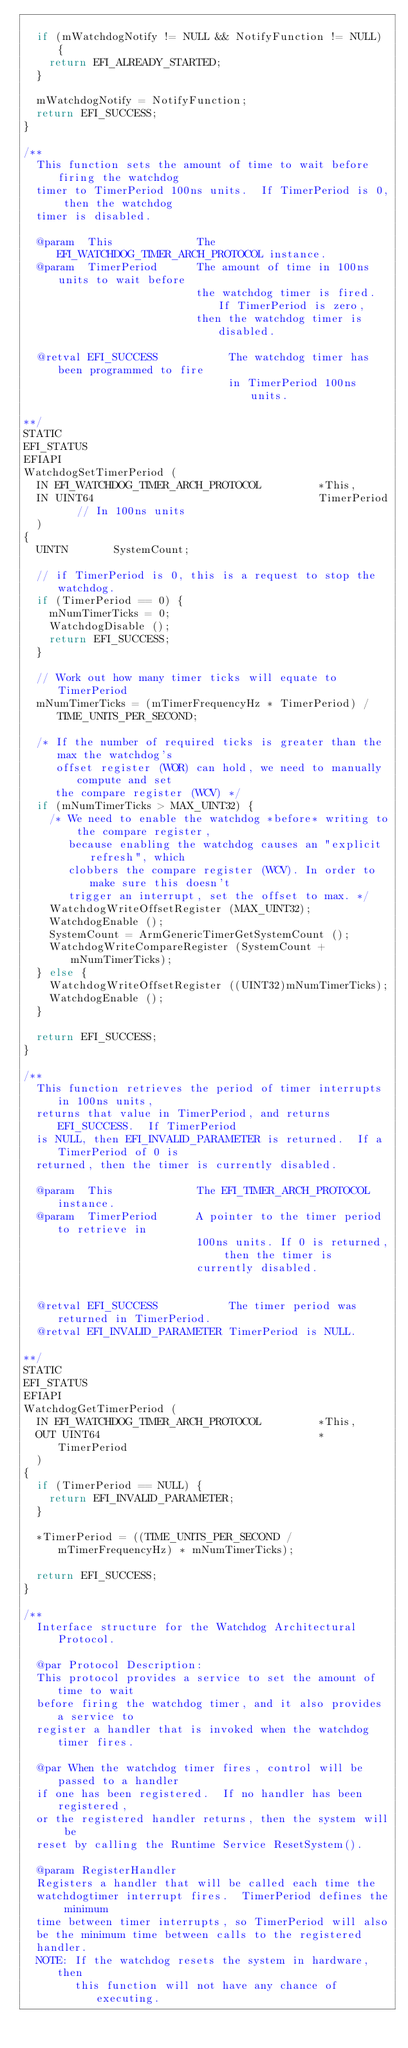Convert code to text. <code><loc_0><loc_0><loc_500><loc_500><_C_>
  if (mWatchdogNotify != NULL && NotifyFunction != NULL) {
    return EFI_ALREADY_STARTED;
  }

  mWatchdogNotify = NotifyFunction;
  return EFI_SUCCESS;
}

/**
  This function sets the amount of time to wait before firing the watchdog
  timer to TimerPeriod 100ns units.  If TimerPeriod is 0, then the watchdog
  timer is disabled.

  @param  This             The EFI_WATCHDOG_TIMER_ARCH_PROTOCOL instance.
  @param  TimerPeriod      The amount of time in 100ns units to wait before
                           the watchdog timer is fired. If TimerPeriod is zero,
                           then the watchdog timer is disabled.

  @retval EFI_SUCCESS           The watchdog timer has been programmed to fire
                                in TimerPeriod 100ns units.

**/
STATIC
EFI_STATUS
EFIAPI
WatchdogSetTimerPeriod (
  IN EFI_WATCHDOG_TIMER_ARCH_PROTOCOL         *This,
  IN UINT64                                   TimerPeriod   // In 100ns units
  )
{
  UINTN       SystemCount;

  // if TimerPeriod is 0, this is a request to stop the watchdog.
  if (TimerPeriod == 0) {
    mNumTimerTicks = 0;
    WatchdogDisable ();
    return EFI_SUCCESS;
  }

  // Work out how many timer ticks will equate to TimerPeriod
  mNumTimerTicks = (mTimerFrequencyHz * TimerPeriod) / TIME_UNITS_PER_SECOND;

  /* If the number of required ticks is greater than the max the watchdog's
     offset register (WOR) can hold, we need to manually compute and set
     the compare register (WCV) */
  if (mNumTimerTicks > MAX_UINT32) {
    /* We need to enable the watchdog *before* writing to the compare register,
       because enabling the watchdog causes an "explicit refresh", which
       clobbers the compare register (WCV). In order to make sure this doesn't
       trigger an interrupt, set the offset to max. */
    WatchdogWriteOffsetRegister (MAX_UINT32);
    WatchdogEnable ();
    SystemCount = ArmGenericTimerGetSystemCount ();
    WatchdogWriteCompareRegister (SystemCount + mNumTimerTicks);
  } else {
    WatchdogWriteOffsetRegister ((UINT32)mNumTimerTicks);
    WatchdogEnable ();
  }

  return EFI_SUCCESS;
}

/**
  This function retrieves the period of timer interrupts in 100ns units,
  returns that value in TimerPeriod, and returns EFI_SUCCESS.  If TimerPeriod
  is NULL, then EFI_INVALID_PARAMETER is returned.  If a TimerPeriod of 0 is
  returned, then the timer is currently disabled.

  @param  This             The EFI_TIMER_ARCH_PROTOCOL instance.
  @param  TimerPeriod      A pointer to the timer period to retrieve in
                           100ns units. If 0 is returned, then the timer is
                           currently disabled.


  @retval EFI_SUCCESS           The timer period was returned in TimerPeriod.
  @retval EFI_INVALID_PARAMETER TimerPeriod is NULL.

**/
STATIC
EFI_STATUS
EFIAPI
WatchdogGetTimerPeriod (
  IN EFI_WATCHDOG_TIMER_ARCH_PROTOCOL         *This,
  OUT UINT64                                  *TimerPeriod
  )
{
  if (TimerPeriod == NULL) {
    return EFI_INVALID_PARAMETER;
  }

  *TimerPeriod = ((TIME_UNITS_PER_SECOND / mTimerFrequencyHz) * mNumTimerTicks);

  return EFI_SUCCESS;
}

/**
  Interface structure for the Watchdog Architectural Protocol.

  @par Protocol Description:
  This protocol provides a service to set the amount of time to wait
  before firing the watchdog timer, and it also provides a service to
  register a handler that is invoked when the watchdog timer fires.

  @par When the watchdog timer fires, control will be passed to a handler
  if one has been registered.  If no handler has been registered,
  or the registered handler returns, then the system will be
  reset by calling the Runtime Service ResetSystem().

  @param RegisterHandler
  Registers a handler that will be called each time the
  watchdogtimer interrupt fires.  TimerPeriod defines the minimum
  time between timer interrupts, so TimerPeriod will also
  be the minimum time between calls to the registered
  handler.
  NOTE: If the watchdog resets the system in hardware, then
        this function will not have any chance of executing.</code> 